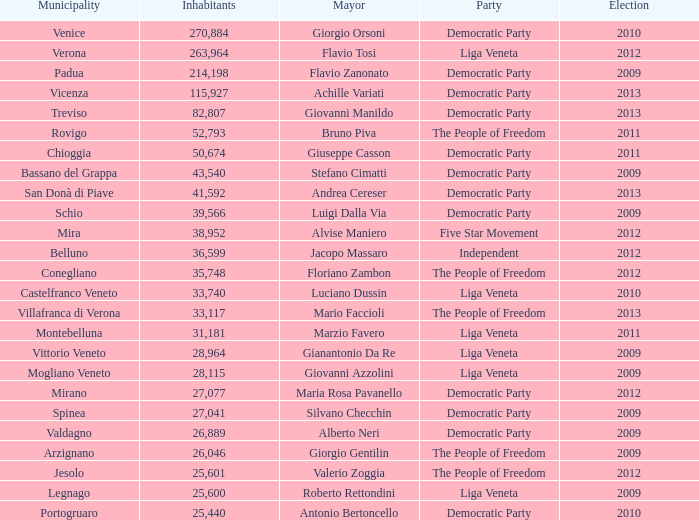How many Inhabitants were in the democratic party for an election before 2009 for Mayor of stefano cimatti? 0.0. 